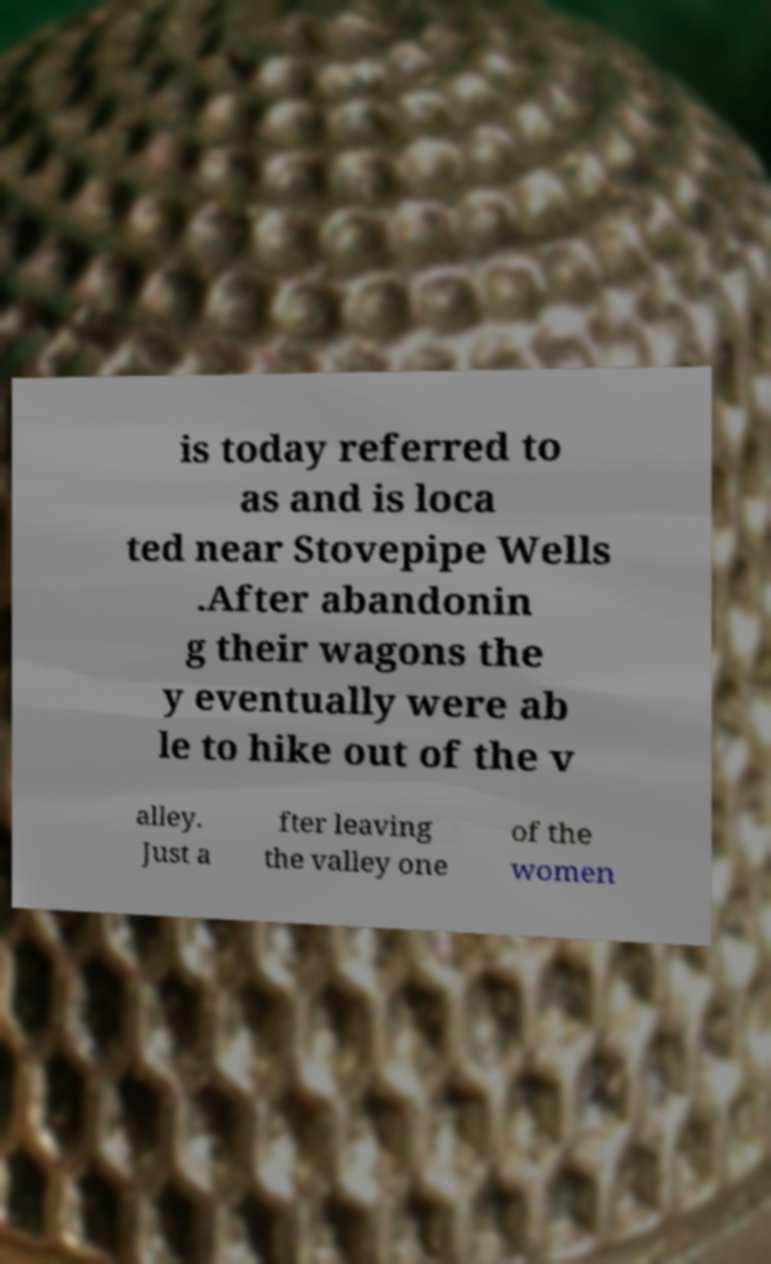Can you read and provide the text displayed in the image?This photo seems to have some interesting text. Can you extract and type it out for me? is today referred to as and is loca ted near Stovepipe Wells .After abandonin g their wagons the y eventually were ab le to hike out of the v alley. Just a fter leaving the valley one of the women 